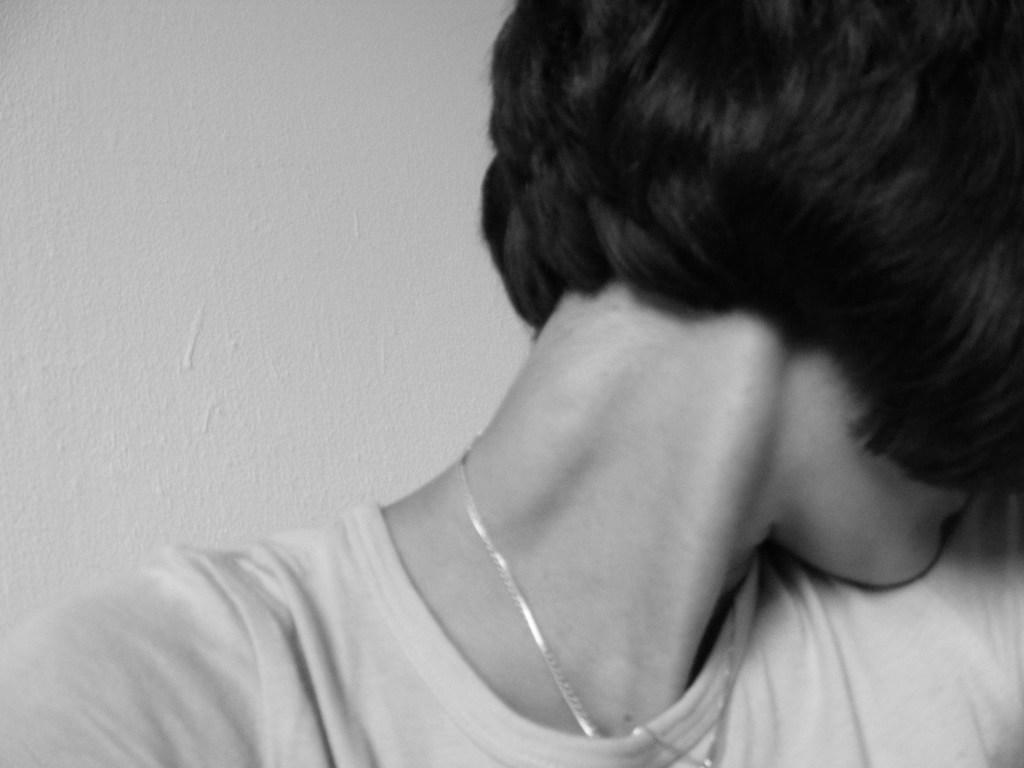Who is the main subject in the image? There is a woman in the image. What is the woman wearing on her upper body? The woman is wearing a t-shirt. Are there any accessories visible on the woman? Yes, the woman is wearing a locket. What can be seen in the background of the image? There is a wall visible in the background of the image. What is the temperature of the cloud in the image? There is no cloud present in the image, so it is not possible to determine the temperature. 